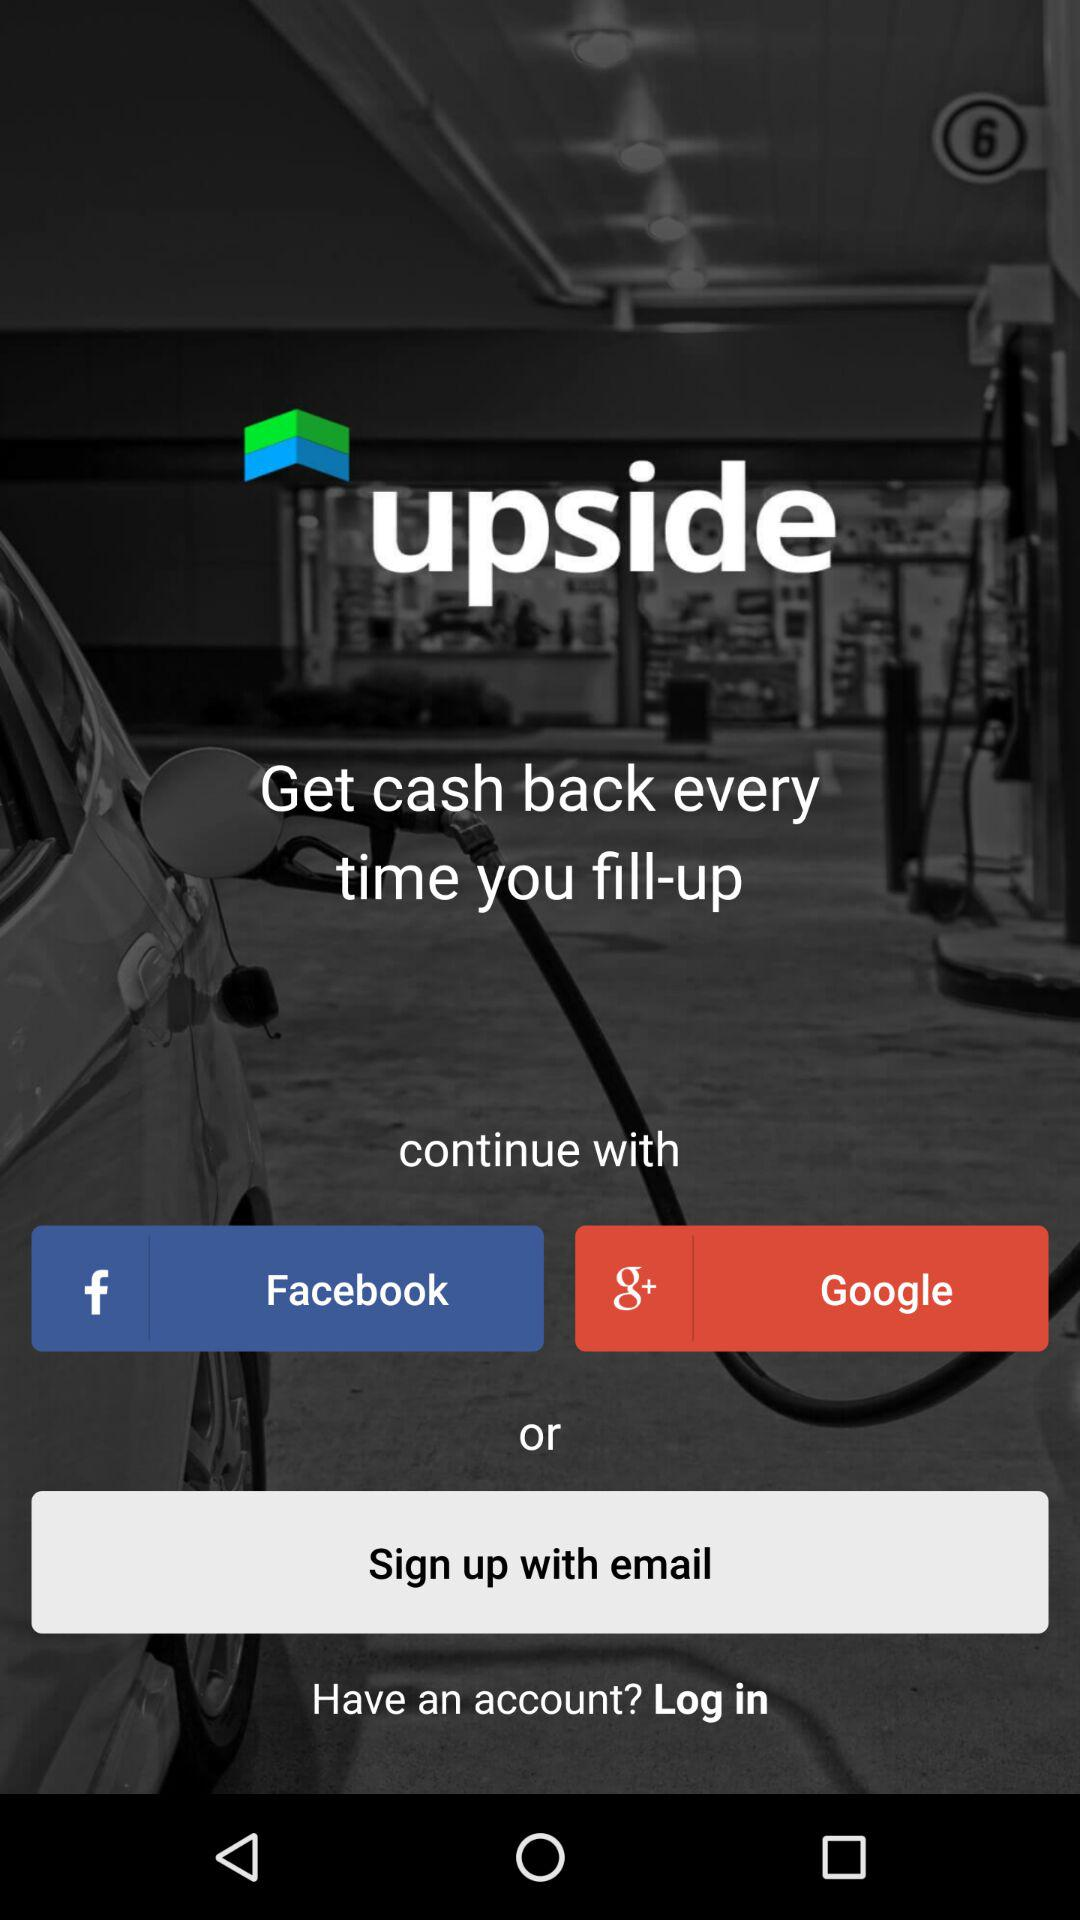Does the user already have an account?
When the provided information is insufficient, respond with <no answer>. <no answer> 